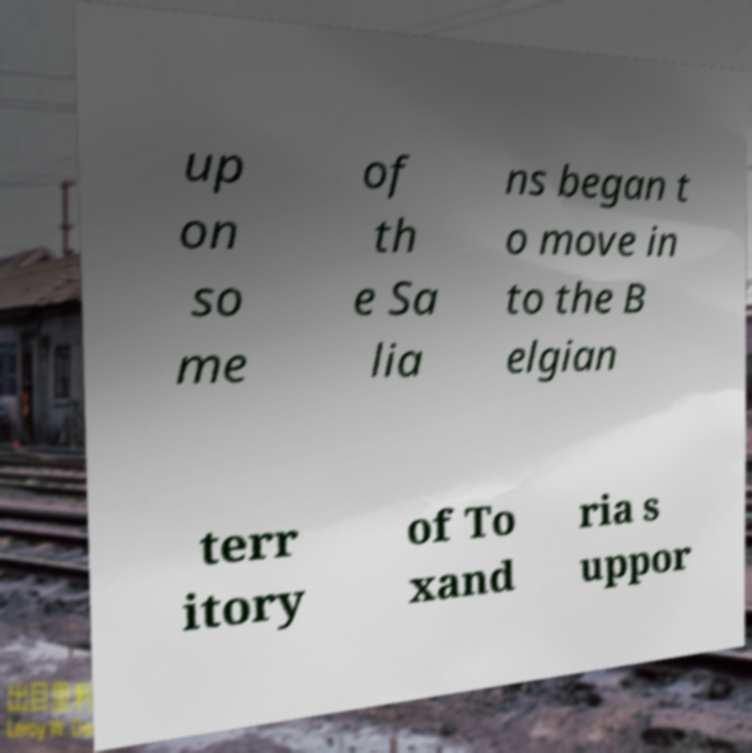Please identify and transcribe the text found in this image. up on so me of th e Sa lia ns began t o move in to the B elgian terr itory of To xand ria s uppor 